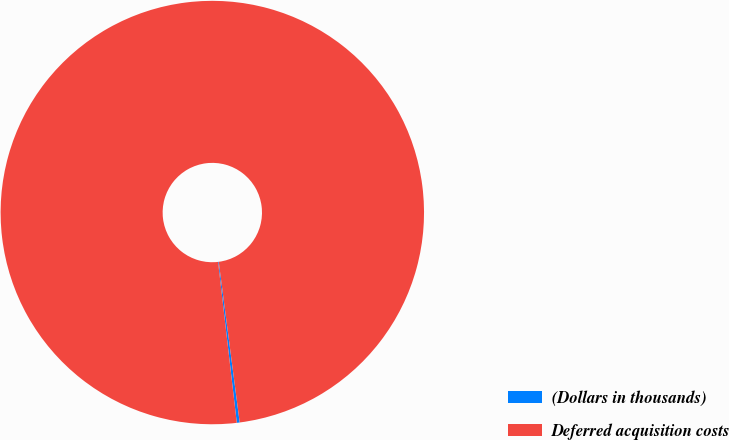Convert chart. <chart><loc_0><loc_0><loc_500><loc_500><pie_chart><fcel>(Dollars in thousands)<fcel>Deferred acquisition costs<nl><fcel>0.22%<fcel>99.78%<nl></chart> 